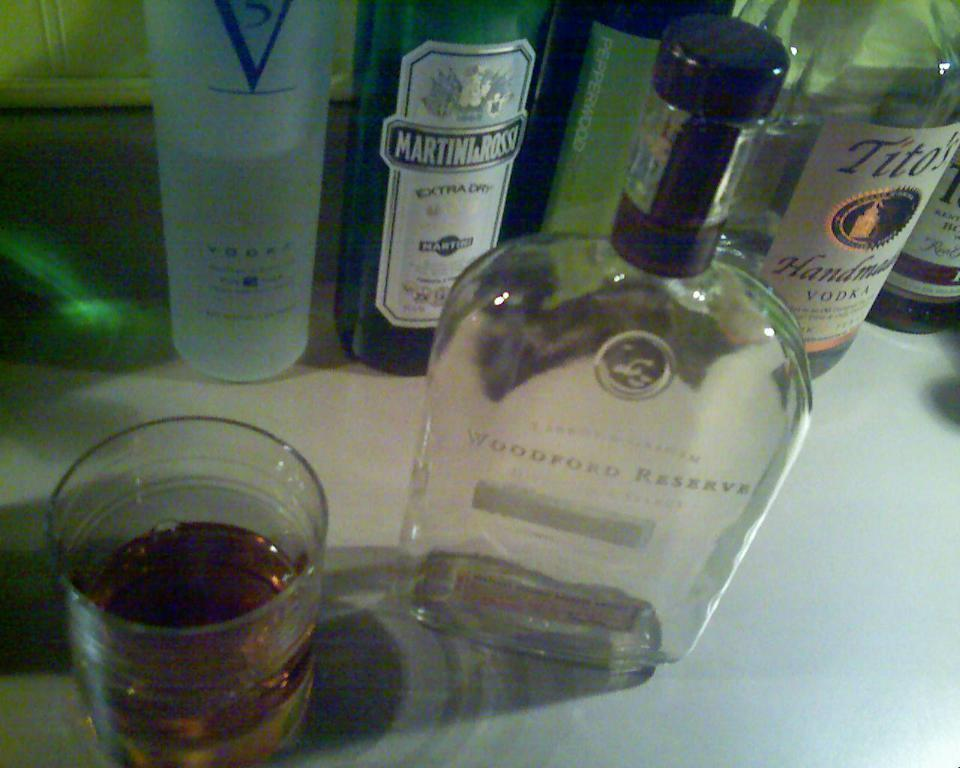<image>
Write a terse but informative summary of the picture. Cup of alcohol next to a bottle that says Titos on it. 